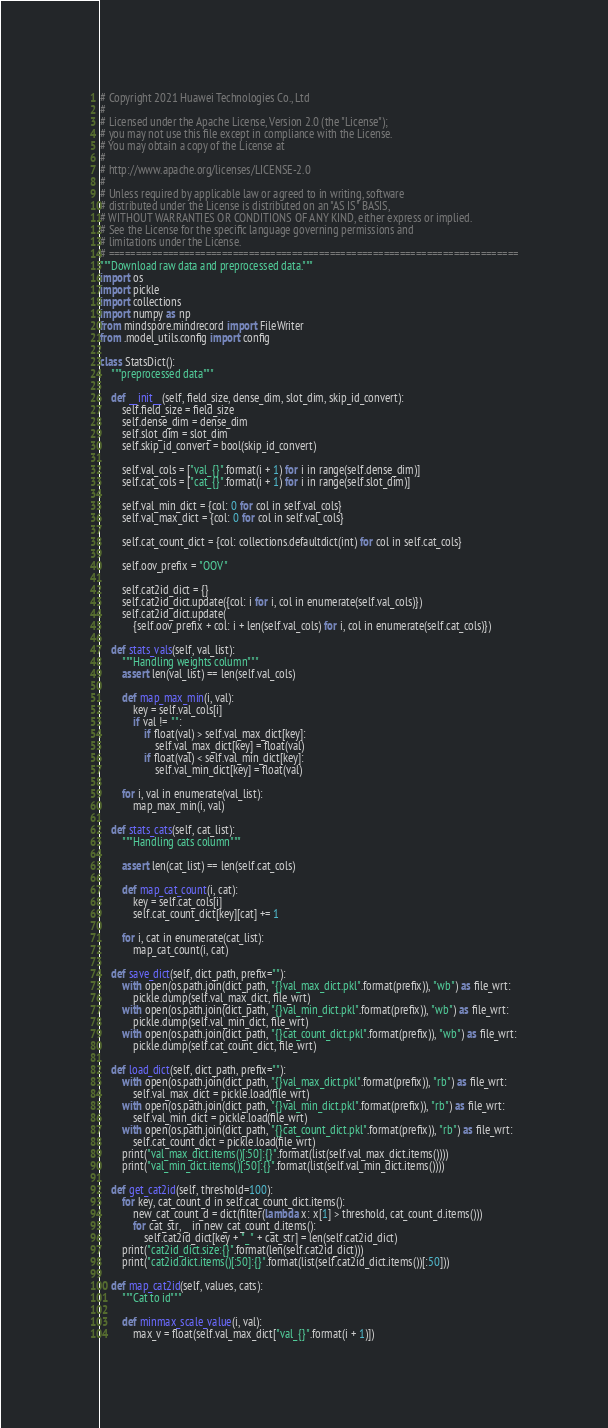<code> <loc_0><loc_0><loc_500><loc_500><_Python_># Copyright 2021 Huawei Technologies Co., Ltd
#
# Licensed under the Apache License, Version 2.0 (the "License");
# you may not use this file except in compliance with the License.
# You may obtain a copy of the License at
#
# http://www.apache.org/licenses/LICENSE-2.0
#
# Unless required by applicable law or agreed to in writing, software
# distributed under the License is distributed on an "AS IS" BASIS,
# WITHOUT WARRANTIES OR CONDITIONS OF ANY KIND, either express or implied.
# See the License for the specific language governing permissions and
# limitations under the License.
# ============================================================================
"""Download raw data and preprocessed data."""
import os
import pickle
import collections
import numpy as np
from mindspore.mindrecord import FileWriter
from .model_utils.config import config

class StatsDict():
    """preprocessed data"""

    def __init__(self, field_size, dense_dim, slot_dim, skip_id_convert):
        self.field_size = field_size
        self.dense_dim = dense_dim
        self.slot_dim = slot_dim
        self.skip_id_convert = bool(skip_id_convert)

        self.val_cols = ["val_{}".format(i + 1) for i in range(self.dense_dim)]
        self.cat_cols = ["cat_{}".format(i + 1) for i in range(self.slot_dim)]

        self.val_min_dict = {col: 0 for col in self.val_cols}
        self.val_max_dict = {col: 0 for col in self.val_cols}

        self.cat_count_dict = {col: collections.defaultdict(int) for col in self.cat_cols}

        self.oov_prefix = "OOV"

        self.cat2id_dict = {}
        self.cat2id_dict.update({col: i for i, col in enumerate(self.val_cols)})
        self.cat2id_dict.update(
            {self.oov_prefix + col: i + len(self.val_cols) for i, col in enumerate(self.cat_cols)})

    def stats_vals(self, val_list):
        """Handling weights column"""
        assert len(val_list) == len(self.val_cols)

        def map_max_min(i, val):
            key = self.val_cols[i]
            if val != "":
                if float(val) > self.val_max_dict[key]:
                    self.val_max_dict[key] = float(val)
                if float(val) < self.val_min_dict[key]:
                    self.val_min_dict[key] = float(val)

        for i, val in enumerate(val_list):
            map_max_min(i, val)

    def stats_cats(self, cat_list):
        """Handling cats column"""

        assert len(cat_list) == len(self.cat_cols)

        def map_cat_count(i, cat):
            key = self.cat_cols[i]
            self.cat_count_dict[key][cat] += 1

        for i, cat in enumerate(cat_list):
            map_cat_count(i, cat)

    def save_dict(self, dict_path, prefix=""):
        with open(os.path.join(dict_path, "{}val_max_dict.pkl".format(prefix)), "wb") as file_wrt:
            pickle.dump(self.val_max_dict, file_wrt)
        with open(os.path.join(dict_path, "{}val_min_dict.pkl".format(prefix)), "wb") as file_wrt:
            pickle.dump(self.val_min_dict, file_wrt)
        with open(os.path.join(dict_path, "{}cat_count_dict.pkl".format(prefix)), "wb") as file_wrt:
            pickle.dump(self.cat_count_dict, file_wrt)

    def load_dict(self, dict_path, prefix=""):
        with open(os.path.join(dict_path, "{}val_max_dict.pkl".format(prefix)), "rb") as file_wrt:
            self.val_max_dict = pickle.load(file_wrt)
        with open(os.path.join(dict_path, "{}val_min_dict.pkl".format(prefix)), "rb") as file_wrt:
            self.val_min_dict = pickle.load(file_wrt)
        with open(os.path.join(dict_path, "{}cat_count_dict.pkl".format(prefix)), "rb") as file_wrt:
            self.cat_count_dict = pickle.load(file_wrt)
        print("val_max_dict.items()[:50]:{}".format(list(self.val_max_dict.items())))
        print("val_min_dict.items()[:50]:{}".format(list(self.val_min_dict.items())))

    def get_cat2id(self, threshold=100):
        for key, cat_count_d in self.cat_count_dict.items():
            new_cat_count_d = dict(filter(lambda x: x[1] > threshold, cat_count_d.items()))
            for cat_str, _ in new_cat_count_d.items():
                self.cat2id_dict[key + "_" + cat_str] = len(self.cat2id_dict)
        print("cat2id_dict.size:{}".format(len(self.cat2id_dict)))
        print("cat2id.dict.items()[:50]:{}".format(list(self.cat2id_dict.items())[:50]))

    def map_cat2id(self, values, cats):
        """Cat to id"""

        def minmax_scale_value(i, val):
            max_v = float(self.val_max_dict["val_{}".format(i + 1)])</code> 